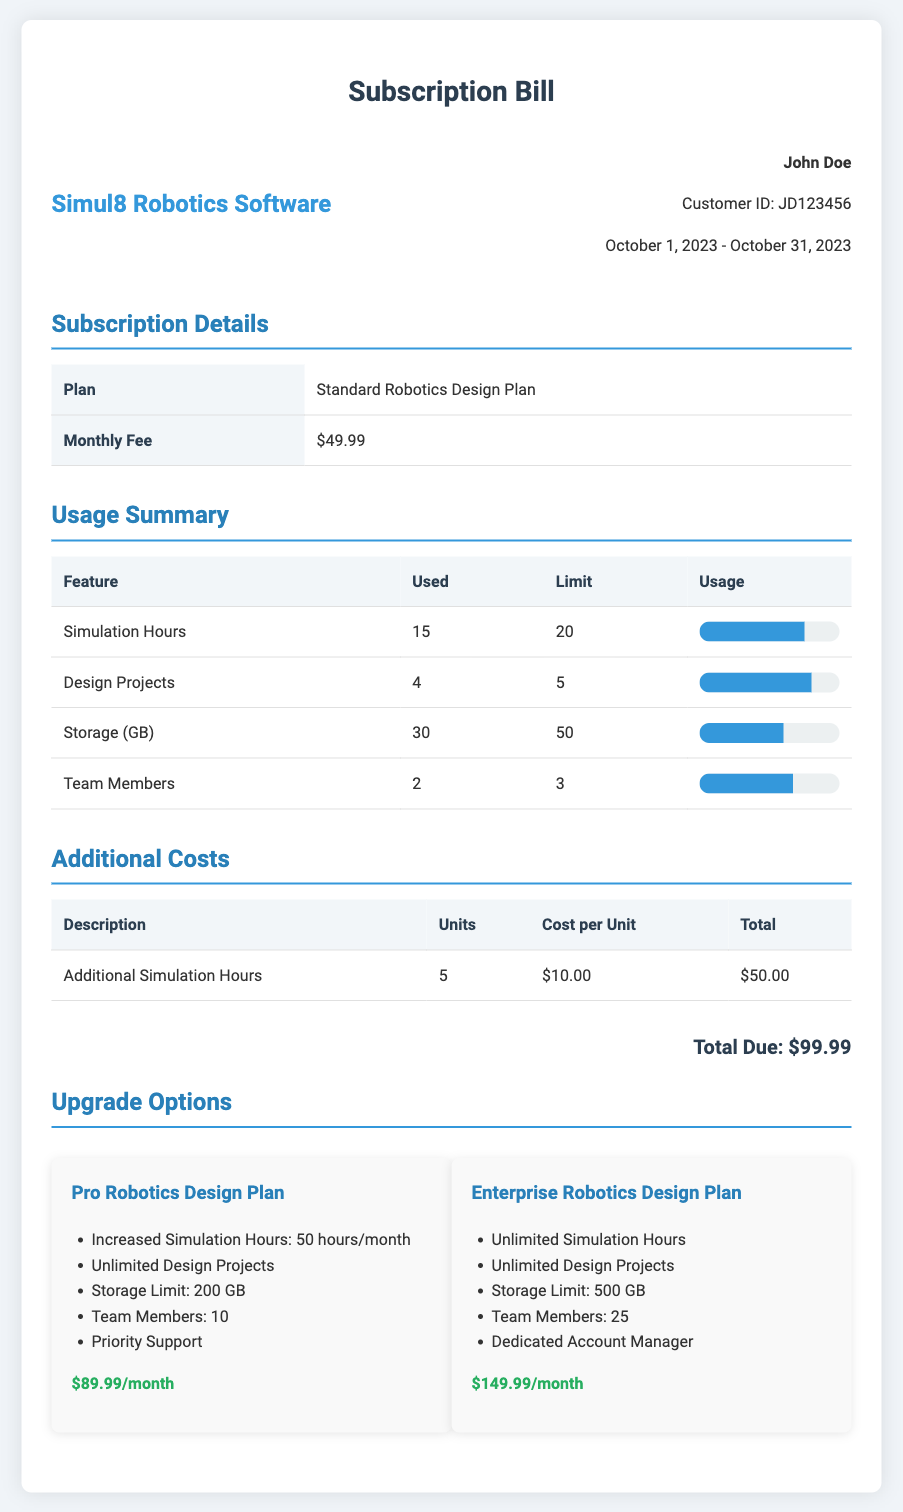What is the customer's name? The customer's name is mentioned in the document.
Answer: John Doe What is the subscription plan called? The name of the subscription plan is stated in the subscription details section.
Answer: Standard Robotics Design Plan What is the monthly fee for the subscription? The monthly fee can be found in the subscription details table.
Answer: $49.99 How many simulation hours have been used? This information is provided in the usage summary section of the document.
Answer: 15 What is the limit for design projects? The limit for design projects is detailed in the usage summary section.
Answer: 5 How much does additional simulation hours cost per unit? The cost per unit for additional simulation hours is listed in the additional costs table.
Answer: $10.00 What is the total due amount on the bill? The total amount due can be found at the end of the document.
Answer: $99.99 What are the benefits of the Pro Robotics Design Plan? The benefits of the Pro plan are listed in the upgrade options section.
Answer: Increased Simulation Hours, Unlimited Design Projects, Storage Limit: 200 GB, Team Members: 10, Priority Support What is the storage limit for the Enterprise Robotics Design Plan? The storage limit is mentioned as a feature of the Enterprise plan in the upgrade options.
Answer: 500 GB How many total team members are allowed under the Standard plan? The limit on team members is specified in the usage summary part of the document.
Answer: 3 